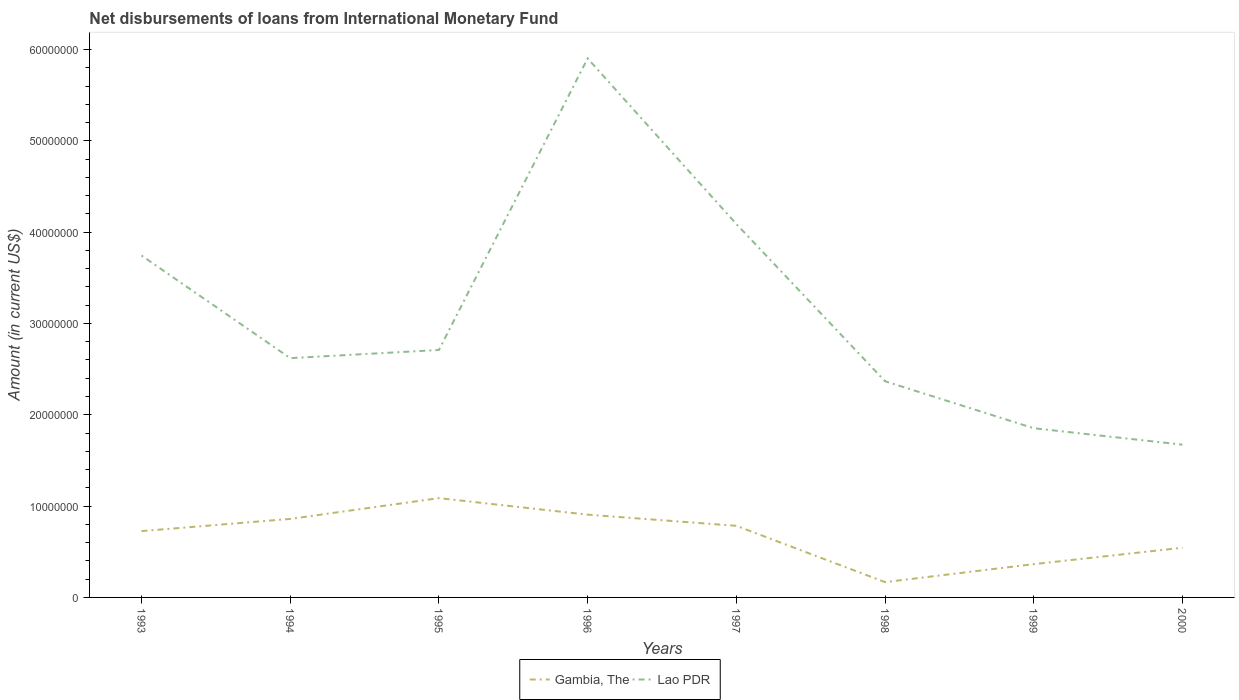Across all years, what is the maximum amount of loans disbursed in Gambia, The?
Provide a succinct answer. 1.68e+06. What is the total amount of loans disbursed in Gambia, The in the graph?
Your answer should be compact. 1.82e+06. What is the difference between the highest and the second highest amount of loans disbursed in Gambia, The?
Keep it short and to the point. 9.19e+06. What is the difference between the highest and the lowest amount of loans disbursed in Lao PDR?
Keep it short and to the point. 3. Is the amount of loans disbursed in Lao PDR strictly greater than the amount of loans disbursed in Gambia, The over the years?
Offer a terse response. No. How many lines are there?
Ensure brevity in your answer.  2. Are the values on the major ticks of Y-axis written in scientific E-notation?
Your answer should be very brief. No. Does the graph contain grids?
Provide a succinct answer. No. How many legend labels are there?
Provide a succinct answer. 2. What is the title of the graph?
Keep it short and to the point. Net disbursements of loans from International Monetary Fund. Does "Botswana" appear as one of the legend labels in the graph?
Your answer should be compact. No. What is the label or title of the X-axis?
Your answer should be very brief. Years. What is the label or title of the Y-axis?
Give a very brief answer. Amount (in current US$). What is the Amount (in current US$) in Gambia, The in 1993?
Offer a very short reply. 7.26e+06. What is the Amount (in current US$) in Lao PDR in 1993?
Make the answer very short. 3.74e+07. What is the Amount (in current US$) in Gambia, The in 1994?
Provide a short and direct response. 8.60e+06. What is the Amount (in current US$) of Lao PDR in 1994?
Make the answer very short. 2.62e+07. What is the Amount (in current US$) of Gambia, The in 1995?
Offer a very short reply. 1.09e+07. What is the Amount (in current US$) of Lao PDR in 1995?
Keep it short and to the point. 2.71e+07. What is the Amount (in current US$) in Gambia, The in 1996?
Make the answer very short. 9.06e+06. What is the Amount (in current US$) of Lao PDR in 1996?
Ensure brevity in your answer.  5.90e+07. What is the Amount (in current US$) of Gambia, The in 1997?
Ensure brevity in your answer.  7.84e+06. What is the Amount (in current US$) in Lao PDR in 1997?
Give a very brief answer. 4.09e+07. What is the Amount (in current US$) of Gambia, The in 1998?
Keep it short and to the point. 1.68e+06. What is the Amount (in current US$) of Lao PDR in 1998?
Provide a succinct answer. 2.37e+07. What is the Amount (in current US$) in Gambia, The in 1999?
Offer a terse response. 3.64e+06. What is the Amount (in current US$) of Lao PDR in 1999?
Give a very brief answer. 1.85e+07. What is the Amount (in current US$) of Gambia, The in 2000?
Your response must be concise. 5.44e+06. What is the Amount (in current US$) of Lao PDR in 2000?
Offer a terse response. 1.67e+07. Across all years, what is the maximum Amount (in current US$) of Gambia, The?
Your answer should be very brief. 1.09e+07. Across all years, what is the maximum Amount (in current US$) in Lao PDR?
Keep it short and to the point. 5.90e+07. Across all years, what is the minimum Amount (in current US$) of Gambia, The?
Provide a succinct answer. 1.68e+06. Across all years, what is the minimum Amount (in current US$) of Lao PDR?
Provide a succinct answer. 1.67e+07. What is the total Amount (in current US$) in Gambia, The in the graph?
Provide a short and direct response. 5.44e+07. What is the total Amount (in current US$) of Lao PDR in the graph?
Offer a terse response. 2.50e+08. What is the difference between the Amount (in current US$) of Gambia, The in 1993 and that in 1994?
Make the answer very short. -1.34e+06. What is the difference between the Amount (in current US$) in Lao PDR in 1993 and that in 1994?
Your response must be concise. 1.12e+07. What is the difference between the Amount (in current US$) of Gambia, The in 1993 and that in 1995?
Ensure brevity in your answer.  -3.61e+06. What is the difference between the Amount (in current US$) of Lao PDR in 1993 and that in 1995?
Provide a short and direct response. 1.03e+07. What is the difference between the Amount (in current US$) of Gambia, The in 1993 and that in 1996?
Offer a very short reply. -1.80e+06. What is the difference between the Amount (in current US$) of Lao PDR in 1993 and that in 1996?
Your response must be concise. -2.16e+07. What is the difference between the Amount (in current US$) in Gambia, The in 1993 and that in 1997?
Give a very brief answer. -5.79e+05. What is the difference between the Amount (in current US$) of Lao PDR in 1993 and that in 1997?
Make the answer very short. -3.45e+06. What is the difference between the Amount (in current US$) in Gambia, The in 1993 and that in 1998?
Your answer should be compact. 5.58e+06. What is the difference between the Amount (in current US$) of Lao PDR in 1993 and that in 1998?
Your response must be concise. 1.38e+07. What is the difference between the Amount (in current US$) of Gambia, The in 1993 and that in 1999?
Your answer should be very brief. 3.62e+06. What is the difference between the Amount (in current US$) of Lao PDR in 1993 and that in 1999?
Give a very brief answer. 1.89e+07. What is the difference between the Amount (in current US$) in Gambia, The in 1993 and that in 2000?
Keep it short and to the point. 1.82e+06. What is the difference between the Amount (in current US$) of Lao PDR in 1993 and that in 2000?
Ensure brevity in your answer.  2.07e+07. What is the difference between the Amount (in current US$) in Gambia, The in 1994 and that in 1995?
Provide a short and direct response. -2.28e+06. What is the difference between the Amount (in current US$) of Lao PDR in 1994 and that in 1995?
Keep it short and to the point. -8.93e+05. What is the difference between the Amount (in current US$) of Gambia, The in 1994 and that in 1996?
Your answer should be compact. -4.66e+05. What is the difference between the Amount (in current US$) of Lao PDR in 1994 and that in 1996?
Provide a succinct answer. -3.28e+07. What is the difference between the Amount (in current US$) in Gambia, The in 1994 and that in 1997?
Provide a succinct answer. 7.56e+05. What is the difference between the Amount (in current US$) of Lao PDR in 1994 and that in 1997?
Offer a terse response. -1.47e+07. What is the difference between the Amount (in current US$) of Gambia, The in 1994 and that in 1998?
Ensure brevity in your answer.  6.92e+06. What is the difference between the Amount (in current US$) in Lao PDR in 1994 and that in 1998?
Your answer should be compact. 2.53e+06. What is the difference between the Amount (in current US$) in Gambia, The in 1994 and that in 1999?
Keep it short and to the point. 4.95e+06. What is the difference between the Amount (in current US$) of Lao PDR in 1994 and that in 1999?
Provide a succinct answer. 7.68e+06. What is the difference between the Amount (in current US$) of Gambia, The in 1994 and that in 2000?
Offer a very short reply. 3.16e+06. What is the difference between the Amount (in current US$) in Lao PDR in 1994 and that in 2000?
Provide a short and direct response. 9.48e+06. What is the difference between the Amount (in current US$) of Gambia, The in 1995 and that in 1996?
Offer a terse response. 1.81e+06. What is the difference between the Amount (in current US$) in Lao PDR in 1995 and that in 1996?
Ensure brevity in your answer.  -3.19e+07. What is the difference between the Amount (in current US$) of Gambia, The in 1995 and that in 1997?
Provide a short and direct response. 3.03e+06. What is the difference between the Amount (in current US$) in Lao PDR in 1995 and that in 1997?
Keep it short and to the point. -1.38e+07. What is the difference between the Amount (in current US$) of Gambia, The in 1995 and that in 1998?
Your response must be concise. 9.19e+06. What is the difference between the Amount (in current US$) of Lao PDR in 1995 and that in 1998?
Offer a terse response. 3.42e+06. What is the difference between the Amount (in current US$) in Gambia, The in 1995 and that in 1999?
Give a very brief answer. 7.23e+06. What is the difference between the Amount (in current US$) of Lao PDR in 1995 and that in 1999?
Your answer should be very brief. 8.57e+06. What is the difference between the Amount (in current US$) of Gambia, The in 1995 and that in 2000?
Offer a terse response. 5.43e+06. What is the difference between the Amount (in current US$) of Lao PDR in 1995 and that in 2000?
Provide a short and direct response. 1.04e+07. What is the difference between the Amount (in current US$) in Gambia, The in 1996 and that in 1997?
Your response must be concise. 1.22e+06. What is the difference between the Amount (in current US$) in Lao PDR in 1996 and that in 1997?
Provide a short and direct response. 1.81e+07. What is the difference between the Amount (in current US$) of Gambia, The in 1996 and that in 1998?
Give a very brief answer. 7.38e+06. What is the difference between the Amount (in current US$) in Lao PDR in 1996 and that in 1998?
Provide a short and direct response. 3.53e+07. What is the difference between the Amount (in current US$) of Gambia, The in 1996 and that in 1999?
Give a very brief answer. 5.42e+06. What is the difference between the Amount (in current US$) of Lao PDR in 1996 and that in 1999?
Provide a short and direct response. 4.05e+07. What is the difference between the Amount (in current US$) in Gambia, The in 1996 and that in 2000?
Keep it short and to the point. 3.62e+06. What is the difference between the Amount (in current US$) in Lao PDR in 1996 and that in 2000?
Provide a short and direct response. 4.23e+07. What is the difference between the Amount (in current US$) of Gambia, The in 1997 and that in 1998?
Give a very brief answer. 6.16e+06. What is the difference between the Amount (in current US$) of Lao PDR in 1997 and that in 1998?
Ensure brevity in your answer.  1.72e+07. What is the difference between the Amount (in current US$) of Gambia, The in 1997 and that in 1999?
Offer a very short reply. 4.20e+06. What is the difference between the Amount (in current US$) in Lao PDR in 1997 and that in 1999?
Ensure brevity in your answer.  2.24e+07. What is the difference between the Amount (in current US$) in Gambia, The in 1997 and that in 2000?
Ensure brevity in your answer.  2.40e+06. What is the difference between the Amount (in current US$) in Lao PDR in 1997 and that in 2000?
Your answer should be compact. 2.42e+07. What is the difference between the Amount (in current US$) of Gambia, The in 1998 and that in 1999?
Provide a succinct answer. -1.97e+06. What is the difference between the Amount (in current US$) of Lao PDR in 1998 and that in 1999?
Provide a succinct answer. 5.15e+06. What is the difference between the Amount (in current US$) of Gambia, The in 1998 and that in 2000?
Provide a short and direct response. -3.76e+06. What is the difference between the Amount (in current US$) of Lao PDR in 1998 and that in 2000?
Keep it short and to the point. 6.94e+06. What is the difference between the Amount (in current US$) of Gambia, The in 1999 and that in 2000?
Your response must be concise. -1.80e+06. What is the difference between the Amount (in current US$) of Lao PDR in 1999 and that in 2000?
Ensure brevity in your answer.  1.80e+06. What is the difference between the Amount (in current US$) in Gambia, The in 1993 and the Amount (in current US$) in Lao PDR in 1994?
Ensure brevity in your answer.  -1.89e+07. What is the difference between the Amount (in current US$) in Gambia, The in 1993 and the Amount (in current US$) in Lao PDR in 1995?
Provide a short and direct response. -1.98e+07. What is the difference between the Amount (in current US$) of Gambia, The in 1993 and the Amount (in current US$) of Lao PDR in 1996?
Ensure brevity in your answer.  -5.18e+07. What is the difference between the Amount (in current US$) of Gambia, The in 1993 and the Amount (in current US$) of Lao PDR in 1997?
Make the answer very short. -3.36e+07. What is the difference between the Amount (in current US$) of Gambia, The in 1993 and the Amount (in current US$) of Lao PDR in 1998?
Keep it short and to the point. -1.64e+07. What is the difference between the Amount (in current US$) in Gambia, The in 1993 and the Amount (in current US$) in Lao PDR in 1999?
Keep it short and to the point. -1.13e+07. What is the difference between the Amount (in current US$) in Gambia, The in 1993 and the Amount (in current US$) in Lao PDR in 2000?
Your response must be concise. -9.46e+06. What is the difference between the Amount (in current US$) of Gambia, The in 1994 and the Amount (in current US$) of Lao PDR in 1995?
Ensure brevity in your answer.  -1.85e+07. What is the difference between the Amount (in current US$) in Gambia, The in 1994 and the Amount (in current US$) in Lao PDR in 1996?
Keep it short and to the point. -5.04e+07. What is the difference between the Amount (in current US$) in Gambia, The in 1994 and the Amount (in current US$) in Lao PDR in 1997?
Your answer should be very brief. -3.23e+07. What is the difference between the Amount (in current US$) of Gambia, The in 1994 and the Amount (in current US$) of Lao PDR in 1998?
Provide a succinct answer. -1.51e+07. What is the difference between the Amount (in current US$) of Gambia, The in 1994 and the Amount (in current US$) of Lao PDR in 1999?
Offer a terse response. -9.93e+06. What is the difference between the Amount (in current US$) of Gambia, The in 1994 and the Amount (in current US$) of Lao PDR in 2000?
Ensure brevity in your answer.  -8.13e+06. What is the difference between the Amount (in current US$) in Gambia, The in 1995 and the Amount (in current US$) in Lao PDR in 1996?
Make the answer very short. -4.81e+07. What is the difference between the Amount (in current US$) of Gambia, The in 1995 and the Amount (in current US$) of Lao PDR in 1997?
Provide a succinct answer. -3.00e+07. What is the difference between the Amount (in current US$) in Gambia, The in 1995 and the Amount (in current US$) in Lao PDR in 1998?
Give a very brief answer. -1.28e+07. What is the difference between the Amount (in current US$) of Gambia, The in 1995 and the Amount (in current US$) of Lao PDR in 1999?
Make the answer very short. -7.65e+06. What is the difference between the Amount (in current US$) of Gambia, The in 1995 and the Amount (in current US$) of Lao PDR in 2000?
Keep it short and to the point. -5.86e+06. What is the difference between the Amount (in current US$) of Gambia, The in 1996 and the Amount (in current US$) of Lao PDR in 1997?
Your answer should be very brief. -3.18e+07. What is the difference between the Amount (in current US$) of Gambia, The in 1996 and the Amount (in current US$) of Lao PDR in 1998?
Make the answer very short. -1.46e+07. What is the difference between the Amount (in current US$) of Gambia, The in 1996 and the Amount (in current US$) of Lao PDR in 1999?
Keep it short and to the point. -9.46e+06. What is the difference between the Amount (in current US$) of Gambia, The in 1996 and the Amount (in current US$) of Lao PDR in 2000?
Keep it short and to the point. -7.66e+06. What is the difference between the Amount (in current US$) of Gambia, The in 1997 and the Amount (in current US$) of Lao PDR in 1998?
Your response must be concise. -1.58e+07. What is the difference between the Amount (in current US$) in Gambia, The in 1997 and the Amount (in current US$) in Lao PDR in 1999?
Make the answer very short. -1.07e+07. What is the difference between the Amount (in current US$) of Gambia, The in 1997 and the Amount (in current US$) of Lao PDR in 2000?
Provide a succinct answer. -8.89e+06. What is the difference between the Amount (in current US$) of Gambia, The in 1998 and the Amount (in current US$) of Lao PDR in 1999?
Your response must be concise. -1.68e+07. What is the difference between the Amount (in current US$) in Gambia, The in 1998 and the Amount (in current US$) in Lao PDR in 2000?
Keep it short and to the point. -1.50e+07. What is the difference between the Amount (in current US$) of Gambia, The in 1999 and the Amount (in current US$) of Lao PDR in 2000?
Offer a terse response. -1.31e+07. What is the average Amount (in current US$) of Gambia, The per year?
Provide a short and direct response. 6.80e+06. What is the average Amount (in current US$) of Lao PDR per year?
Your answer should be compact. 3.12e+07. In the year 1993, what is the difference between the Amount (in current US$) of Gambia, The and Amount (in current US$) of Lao PDR?
Offer a very short reply. -3.02e+07. In the year 1994, what is the difference between the Amount (in current US$) of Gambia, The and Amount (in current US$) of Lao PDR?
Your answer should be very brief. -1.76e+07. In the year 1995, what is the difference between the Amount (in current US$) in Gambia, The and Amount (in current US$) in Lao PDR?
Your response must be concise. -1.62e+07. In the year 1996, what is the difference between the Amount (in current US$) in Gambia, The and Amount (in current US$) in Lao PDR?
Offer a very short reply. -5.00e+07. In the year 1997, what is the difference between the Amount (in current US$) of Gambia, The and Amount (in current US$) of Lao PDR?
Your response must be concise. -3.30e+07. In the year 1998, what is the difference between the Amount (in current US$) in Gambia, The and Amount (in current US$) in Lao PDR?
Provide a succinct answer. -2.20e+07. In the year 1999, what is the difference between the Amount (in current US$) in Gambia, The and Amount (in current US$) in Lao PDR?
Your answer should be very brief. -1.49e+07. In the year 2000, what is the difference between the Amount (in current US$) in Gambia, The and Amount (in current US$) in Lao PDR?
Ensure brevity in your answer.  -1.13e+07. What is the ratio of the Amount (in current US$) in Gambia, The in 1993 to that in 1994?
Offer a very short reply. 0.84. What is the ratio of the Amount (in current US$) of Lao PDR in 1993 to that in 1994?
Your answer should be very brief. 1.43. What is the ratio of the Amount (in current US$) in Gambia, The in 1993 to that in 1995?
Offer a very short reply. 0.67. What is the ratio of the Amount (in current US$) of Lao PDR in 1993 to that in 1995?
Keep it short and to the point. 1.38. What is the ratio of the Amount (in current US$) in Gambia, The in 1993 to that in 1996?
Your response must be concise. 0.8. What is the ratio of the Amount (in current US$) in Lao PDR in 1993 to that in 1996?
Offer a very short reply. 0.63. What is the ratio of the Amount (in current US$) of Gambia, The in 1993 to that in 1997?
Offer a terse response. 0.93. What is the ratio of the Amount (in current US$) in Lao PDR in 1993 to that in 1997?
Provide a succinct answer. 0.92. What is the ratio of the Amount (in current US$) of Gambia, The in 1993 to that in 1998?
Your answer should be compact. 4.33. What is the ratio of the Amount (in current US$) of Lao PDR in 1993 to that in 1998?
Keep it short and to the point. 1.58. What is the ratio of the Amount (in current US$) of Gambia, The in 1993 to that in 1999?
Make the answer very short. 1.99. What is the ratio of the Amount (in current US$) in Lao PDR in 1993 to that in 1999?
Offer a very short reply. 2.02. What is the ratio of the Amount (in current US$) of Gambia, The in 1993 to that in 2000?
Your answer should be compact. 1.34. What is the ratio of the Amount (in current US$) in Lao PDR in 1993 to that in 2000?
Your answer should be very brief. 2.24. What is the ratio of the Amount (in current US$) in Gambia, The in 1994 to that in 1995?
Your answer should be very brief. 0.79. What is the ratio of the Amount (in current US$) in Gambia, The in 1994 to that in 1996?
Give a very brief answer. 0.95. What is the ratio of the Amount (in current US$) in Lao PDR in 1994 to that in 1996?
Your response must be concise. 0.44. What is the ratio of the Amount (in current US$) of Gambia, The in 1994 to that in 1997?
Give a very brief answer. 1.1. What is the ratio of the Amount (in current US$) in Lao PDR in 1994 to that in 1997?
Your answer should be very brief. 0.64. What is the ratio of the Amount (in current US$) in Gambia, The in 1994 to that in 1998?
Offer a very short reply. 5.12. What is the ratio of the Amount (in current US$) in Lao PDR in 1994 to that in 1998?
Your answer should be very brief. 1.11. What is the ratio of the Amount (in current US$) in Gambia, The in 1994 to that in 1999?
Your answer should be compact. 2.36. What is the ratio of the Amount (in current US$) of Lao PDR in 1994 to that in 1999?
Provide a short and direct response. 1.41. What is the ratio of the Amount (in current US$) in Gambia, The in 1994 to that in 2000?
Offer a terse response. 1.58. What is the ratio of the Amount (in current US$) in Lao PDR in 1994 to that in 2000?
Your response must be concise. 1.57. What is the ratio of the Amount (in current US$) in Gambia, The in 1995 to that in 1996?
Keep it short and to the point. 1.2. What is the ratio of the Amount (in current US$) of Lao PDR in 1995 to that in 1996?
Your response must be concise. 0.46. What is the ratio of the Amount (in current US$) in Gambia, The in 1995 to that in 1997?
Your answer should be very brief. 1.39. What is the ratio of the Amount (in current US$) of Lao PDR in 1995 to that in 1997?
Offer a terse response. 0.66. What is the ratio of the Amount (in current US$) in Gambia, The in 1995 to that in 1998?
Your answer should be compact. 6.48. What is the ratio of the Amount (in current US$) of Lao PDR in 1995 to that in 1998?
Offer a terse response. 1.14. What is the ratio of the Amount (in current US$) of Gambia, The in 1995 to that in 1999?
Make the answer very short. 2.98. What is the ratio of the Amount (in current US$) in Lao PDR in 1995 to that in 1999?
Provide a succinct answer. 1.46. What is the ratio of the Amount (in current US$) in Gambia, The in 1995 to that in 2000?
Your answer should be very brief. 2. What is the ratio of the Amount (in current US$) of Lao PDR in 1995 to that in 2000?
Provide a succinct answer. 1.62. What is the ratio of the Amount (in current US$) in Gambia, The in 1996 to that in 1997?
Offer a very short reply. 1.16. What is the ratio of the Amount (in current US$) in Lao PDR in 1996 to that in 1997?
Your answer should be compact. 1.44. What is the ratio of the Amount (in current US$) of Gambia, The in 1996 to that in 1998?
Offer a terse response. 5.4. What is the ratio of the Amount (in current US$) in Lao PDR in 1996 to that in 1998?
Your answer should be compact. 2.49. What is the ratio of the Amount (in current US$) of Gambia, The in 1996 to that in 1999?
Make the answer very short. 2.49. What is the ratio of the Amount (in current US$) in Lao PDR in 1996 to that in 1999?
Provide a short and direct response. 3.19. What is the ratio of the Amount (in current US$) of Gambia, The in 1996 to that in 2000?
Offer a very short reply. 1.67. What is the ratio of the Amount (in current US$) in Lao PDR in 1996 to that in 2000?
Provide a succinct answer. 3.53. What is the ratio of the Amount (in current US$) of Gambia, The in 1997 to that in 1998?
Offer a very short reply. 4.67. What is the ratio of the Amount (in current US$) of Lao PDR in 1997 to that in 1998?
Your answer should be compact. 1.73. What is the ratio of the Amount (in current US$) in Gambia, The in 1997 to that in 1999?
Offer a very short reply. 2.15. What is the ratio of the Amount (in current US$) in Lao PDR in 1997 to that in 1999?
Your response must be concise. 2.21. What is the ratio of the Amount (in current US$) in Gambia, The in 1997 to that in 2000?
Provide a short and direct response. 1.44. What is the ratio of the Amount (in current US$) of Lao PDR in 1997 to that in 2000?
Keep it short and to the point. 2.44. What is the ratio of the Amount (in current US$) of Gambia, The in 1998 to that in 1999?
Give a very brief answer. 0.46. What is the ratio of the Amount (in current US$) in Lao PDR in 1998 to that in 1999?
Your answer should be compact. 1.28. What is the ratio of the Amount (in current US$) in Gambia, The in 1998 to that in 2000?
Your answer should be very brief. 0.31. What is the ratio of the Amount (in current US$) of Lao PDR in 1998 to that in 2000?
Your response must be concise. 1.42. What is the ratio of the Amount (in current US$) in Gambia, The in 1999 to that in 2000?
Keep it short and to the point. 0.67. What is the ratio of the Amount (in current US$) of Lao PDR in 1999 to that in 2000?
Provide a succinct answer. 1.11. What is the difference between the highest and the second highest Amount (in current US$) in Gambia, The?
Provide a succinct answer. 1.81e+06. What is the difference between the highest and the second highest Amount (in current US$) of Lao PDR?
Keep it short and to the point. 1.81e+07. What is the difference between the highest and the lowest Amount (in current US$) of Gambia, The?
Your answer should be very brief. 9.19e+06. What is the difference between the highest and the lowest Amount (in current US$) of Lao PDR?
Ensure brevity in your answer.  4.23e+07. 